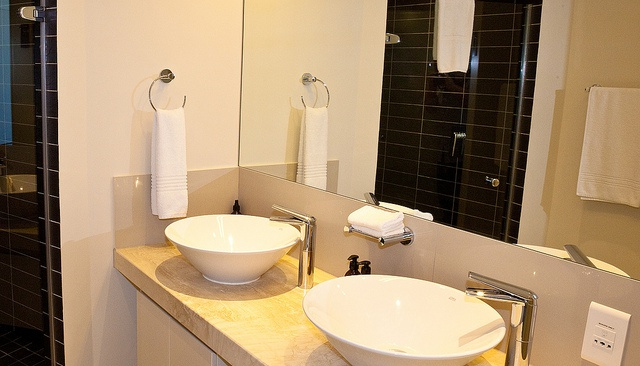Describe the objects in this image and their specific colors. I can see sink in teal, beige, tan, and black tones and bowl in teal, beige, and tan tones in this image. 